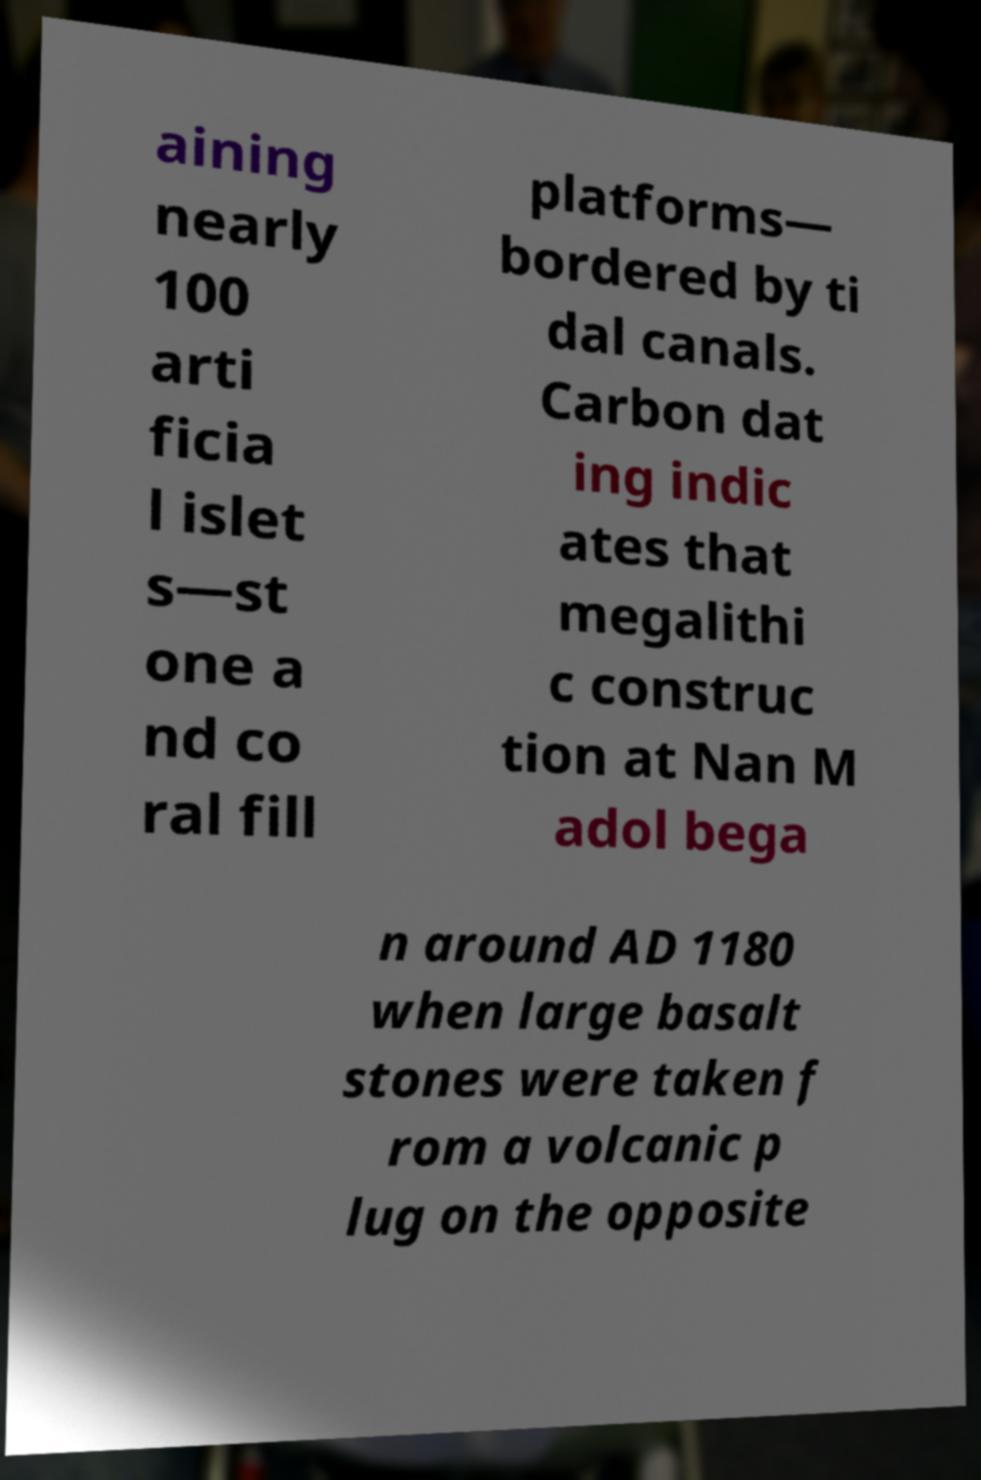Can you accurately transcribe the text from the provided image for me? aining nearly 100 arti ficia l islet s—st one a nd co ral fill platforms— bordered by ti dal canals. Carbon dat ing indic ates that megalithi c construc tion at Nan M adol bega n around AD 1180 when large basalt stones were taken f rom a volcanic p lug on the opposite 